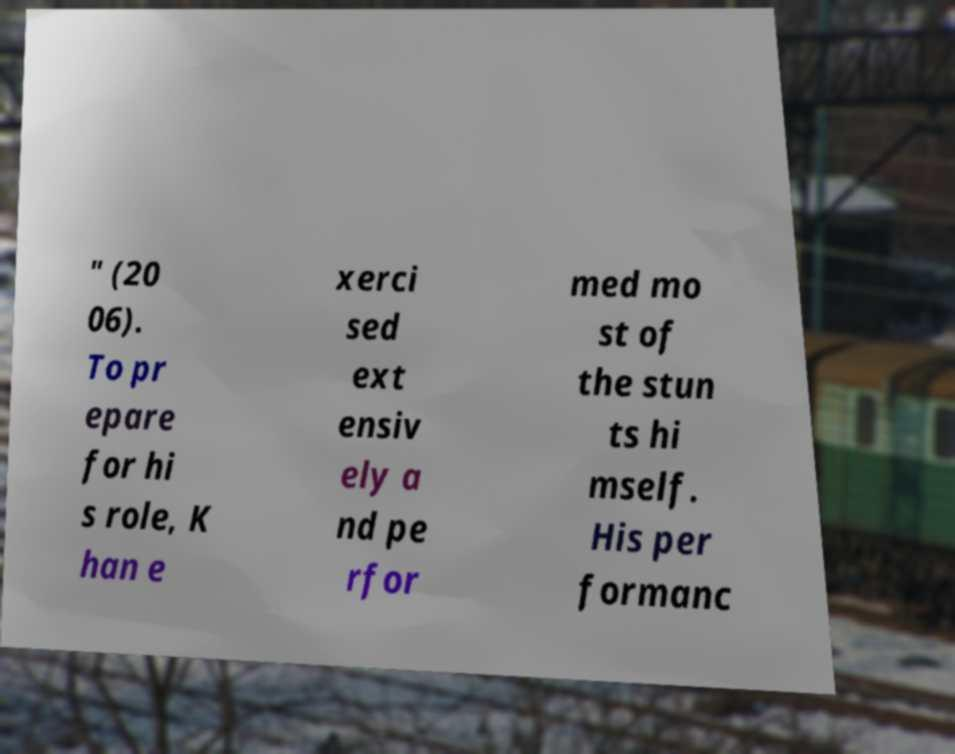I need the written content from this picture converted into text. Can you do that? " (20 06). To pr epare for hi s role, K han e xerci sed ext ensiv ely a nd pe rfor med mo st of the stun ts hi mself. His per formanc 